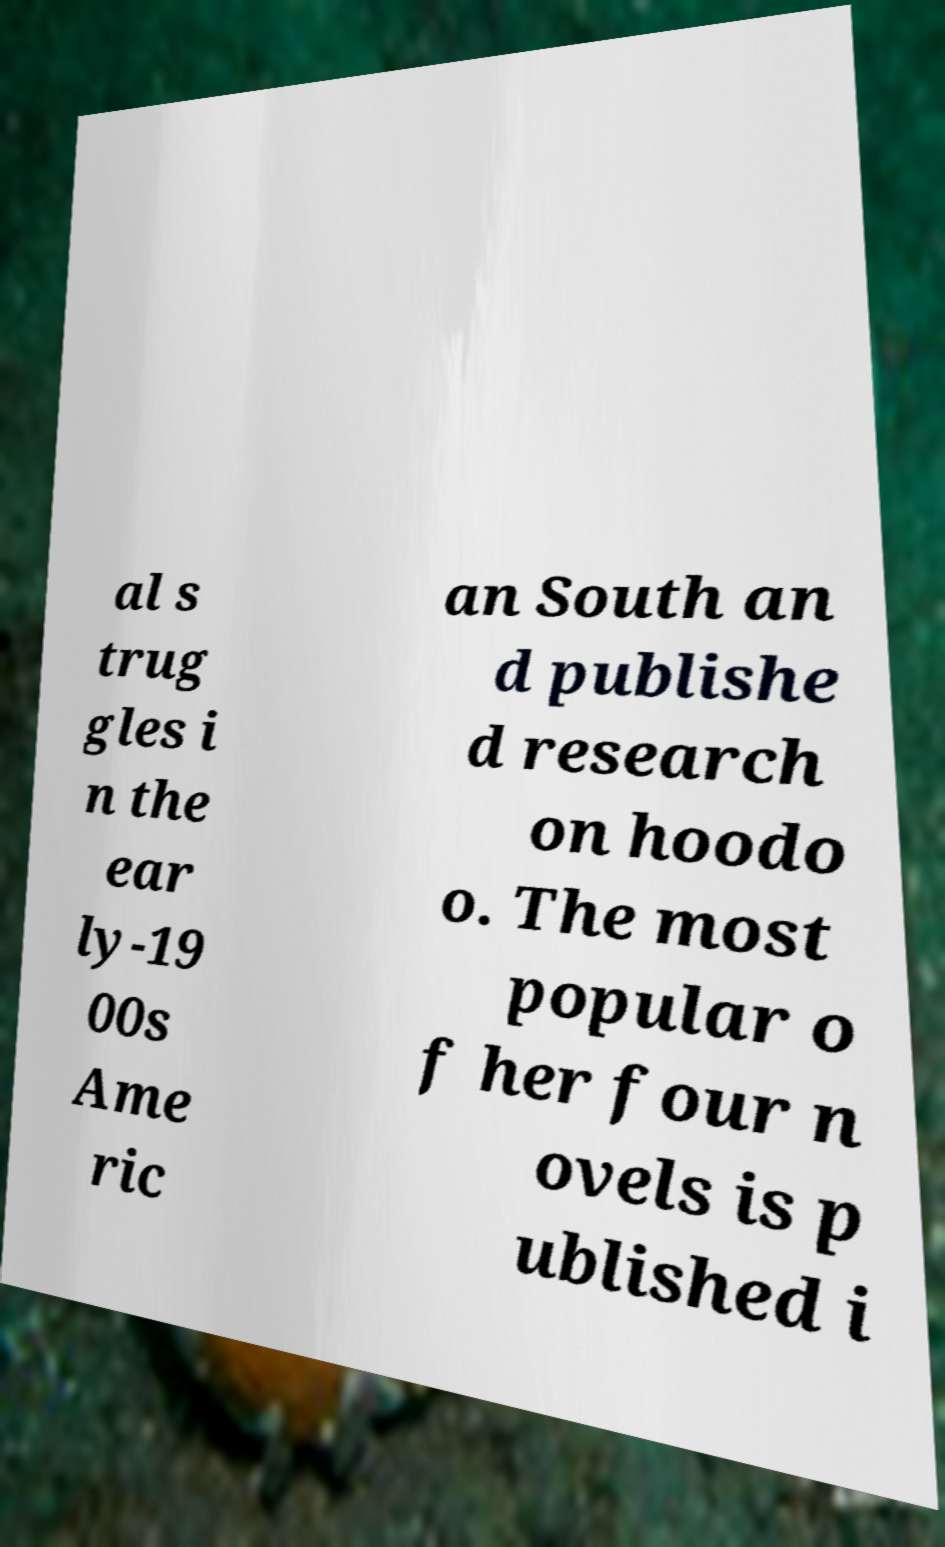What messages or text are displayed in this image? I need them in a readable, typed format. al s trug gles i n the ear ly-19 00s Ame ric an South an d publishe d research on hoodo o. The most popular o f her four n ovels is p ublished i 